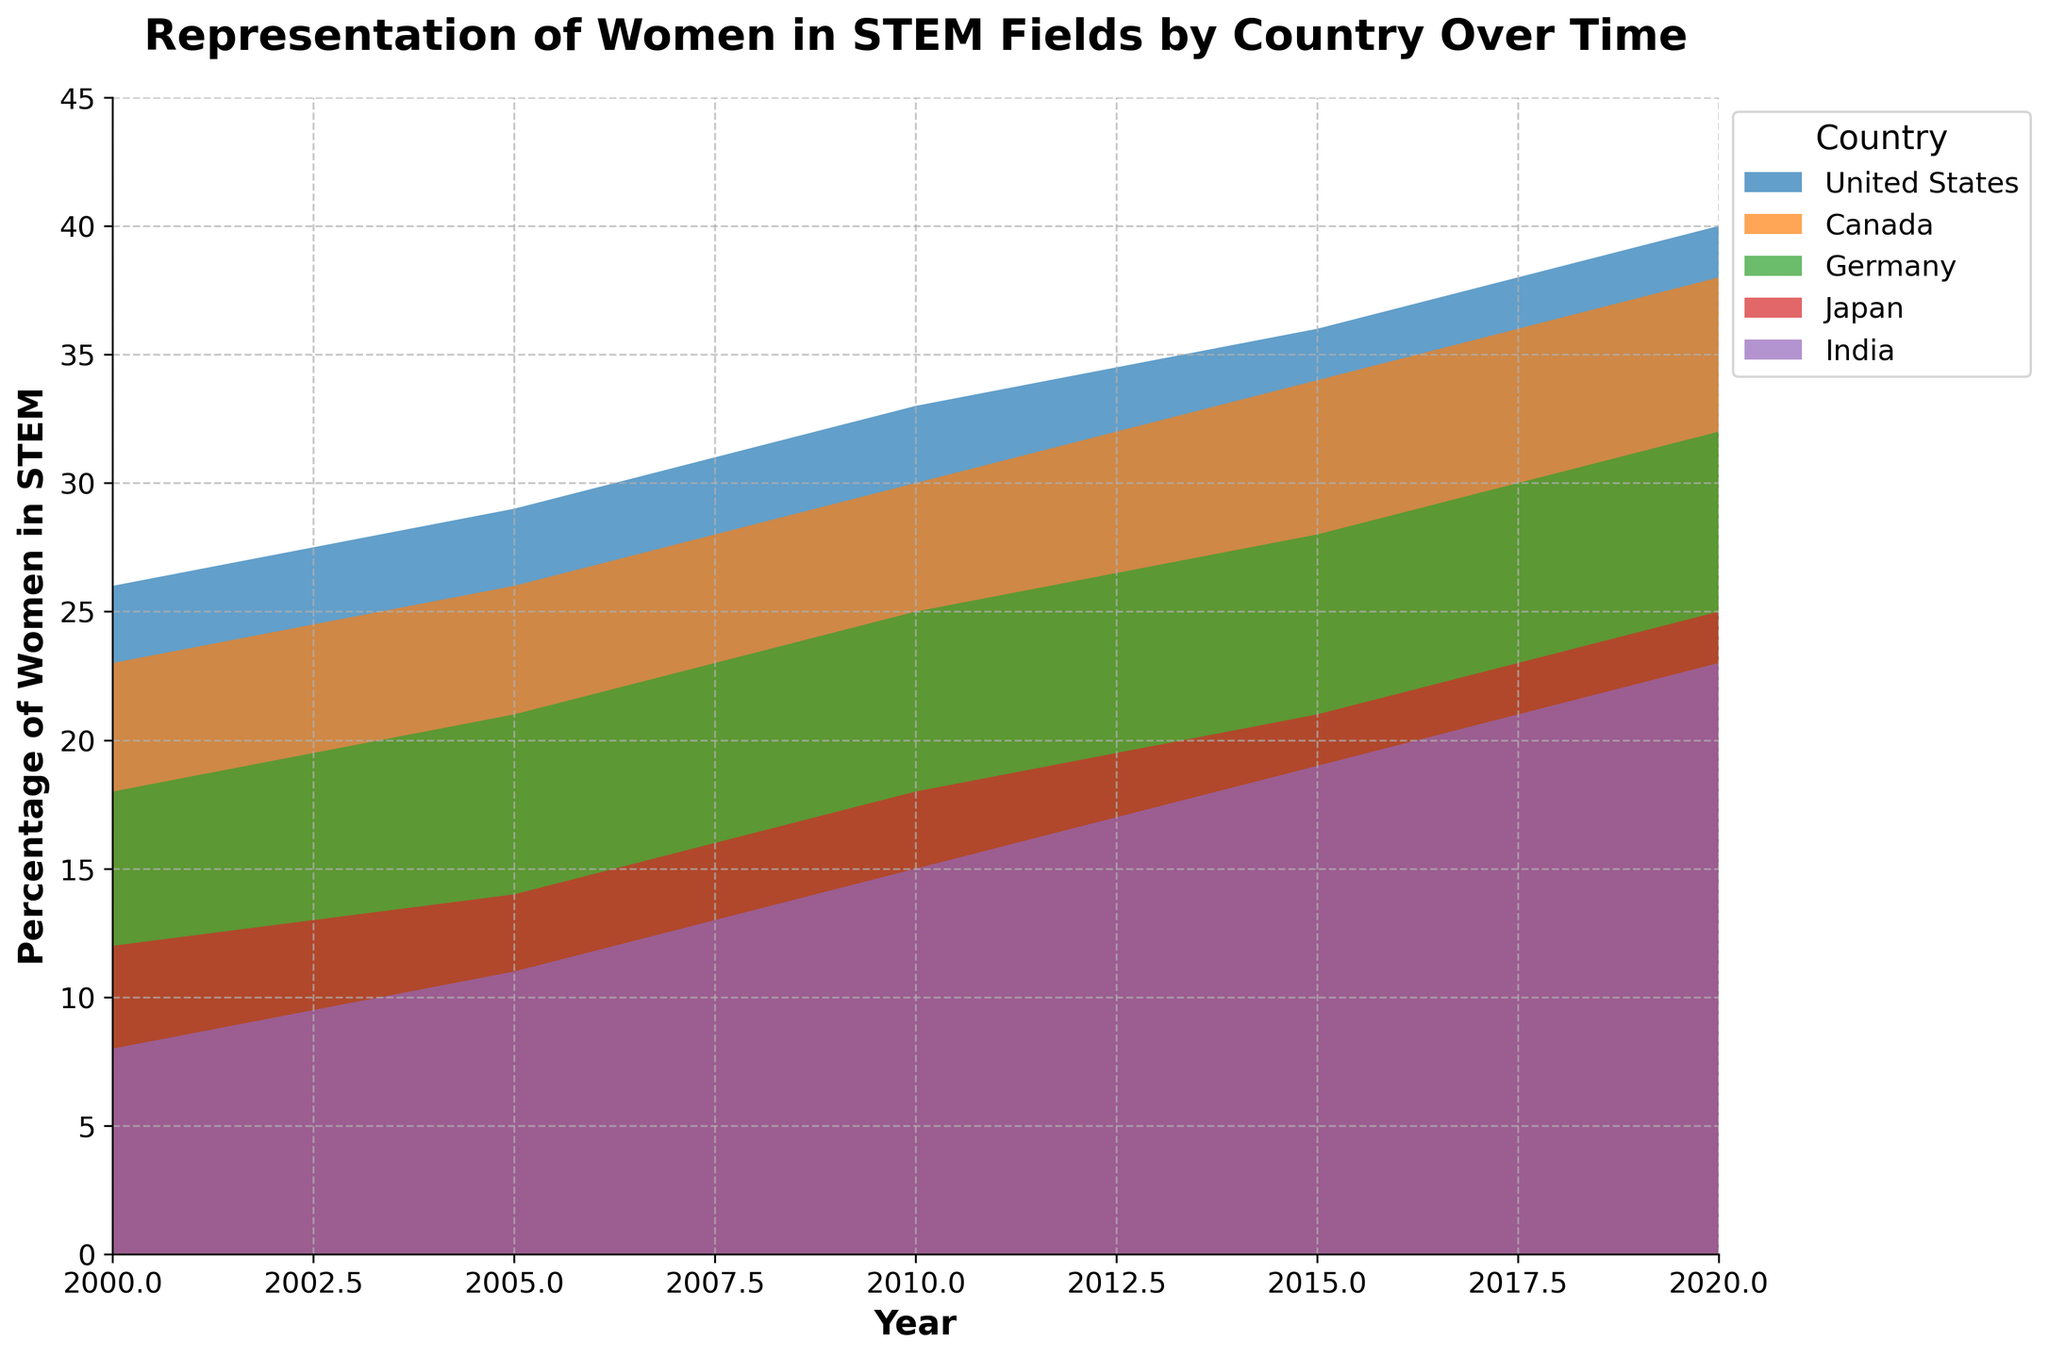what is the title of the figure? The title is located at the top of the figure and is typically bold and slightly larger in font size. It is "Representation of Women in STEM Fields by Country Over Time."
Answer: Representation of Women in STEM Fields by Country Over Time How many countries are represented in this chart? Each country is represented by a distinct area in the chart, often labeled in the legend. Counting these entries identifies 5 distinct countries.
Answer: 5 Which country shows the highest percentage of women in STEM in 2020? The data for 2020 shows the end of each country's trend line. The country with the highest value at this point is the United States, reaching 40%.
Answer: United States How did the percentage of women in STEM in Japan change from 2000 to 2020? Locate Japan's starting value in 2000 (12%) and its ending value in 2020 (25%). Compute the difference by subtracting the former from the latter: 25% - 12% = 13%.
Answer: Increased by 13% Which countries show a consistent increase in women's representation in STEM from 2000 to 2020? Checking the trend lines for each country, all countries (United States, Canada, Germany, Japan, and India) show an upward slope from 2000 to 2020, thus all exhibit a consistent increase.
Answer: United States, Canada, Germany, Japan, India What is the average percentage of women in STEM in Germany across all the given years? For Germany, sum its percentages (18 + 21 + 25 + 28 + 32) and divide by the number of years (5): (18 + 21 + 25 + 28 + 32) / 5 = 24.8%.
Answer: 24.8% Compare the change in percentage of women in STEM between 2000 and 2020 in the United States and Canada. Which country saw a greater increase? Compute the change: United States (40% - 26% = 14%), Canada (38% - 23% = 15%). Canada saw a greater increase (15% vs. 14%).
Answer: Canada What is the combined percentage increase of women in STEM in both India and Germany from 2000 to 2020? Germany's increase is 32% - 18% = 14%, India's increase is 23% - 8% = 15%. The combined increase is 14% + 15% = 29%.
Answer: 29% Which country had the lowest percentage of women in STEM in 2010, and what was it? For 2010, check each country's data and find the lowest value, which is India with 15%.
Answer: India, 15% By how much did the percentage of women in STEM increase in Canada from 2005 to 2015? From 2005 to 2015, Canada's values are 26% and 34%. The increase is calculated as 34% - 26% = 8%.
Answer: 8% 